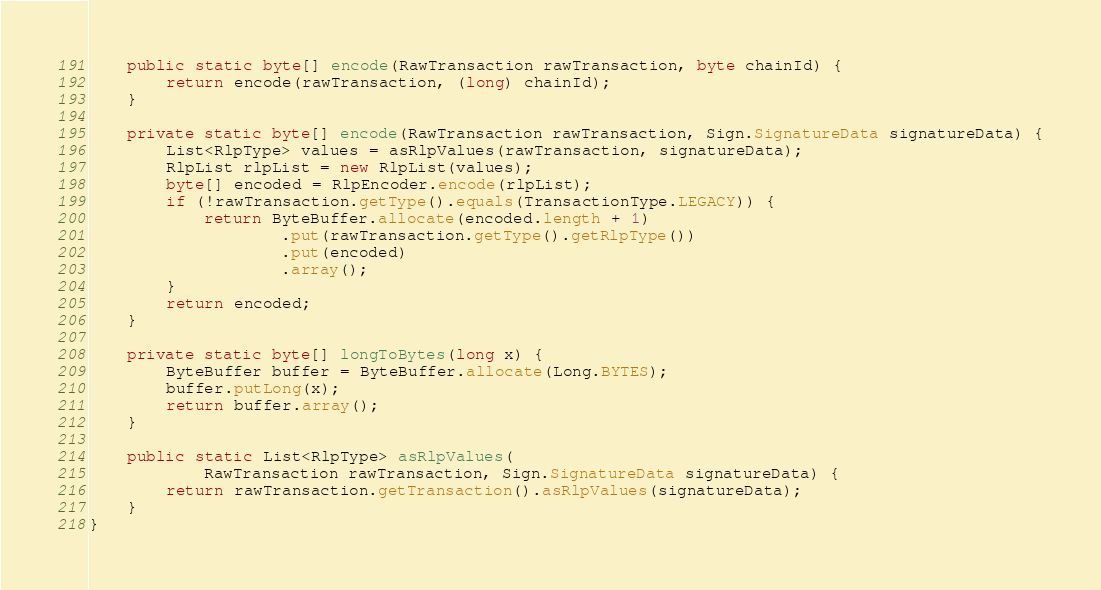Convert code to text. <code><loc_0><loc_0><loc_500><loc_500><_Java_>    public static byte[] encode(RawTransaction rawTransaction, byte chainId) {
        return encode(rawTransaction, (long) chainId);
    }

    private static byte[] encode(RawTransaction rawTransaction, Sign.SignatureData signatureData) {
        List<RlpType> values = asRlpValues(rawTransaction, signatureData);
        RlpList rlpList = new RlpList(values);
        byte[] encoded = RlpEncoder.encode(rlpList);
        if (!rawTransaction.getType().equals(TransactionType.LEGACY)) {
            return ByteBuffer.allocate(encoded.length + 1)
                    .put(rawTransaction.getType().getRlpType())
                    .put(encoded)
                    .array();
        }
        return encoded;
    }

    private static byte[] longToBytes(long x) {
        ByteBuffer buffer = ByteBuffer.allocate(Long.BYTES);
        buffer.putLong(x);
        return buffer.array();
    }

    public static List<RlpType> asRlpValues(
            RawTransaction rawTransaction, Sign.SignatureData signatureData) {
        return rawTransaction.getTransaction().asRlpValues(signatureData);
    }
}
</code> 